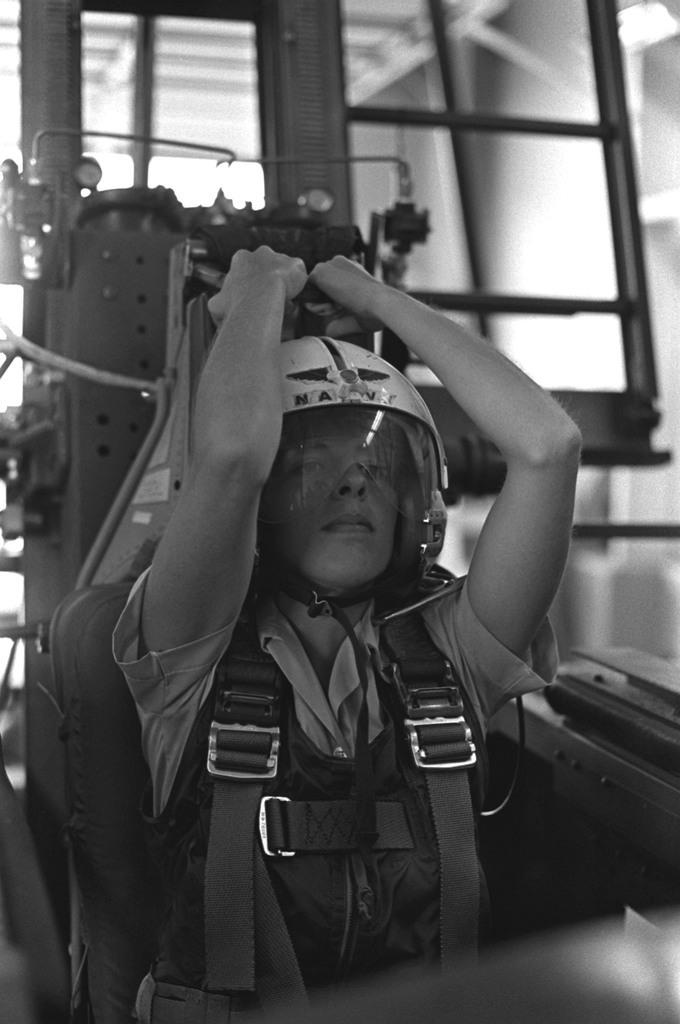Who is present in the image? There is a woman in the image. What is the woman doing in the image? The woman is sitting. What type of clothing is the woman wearing in the image? The woman is wearing a jacket and a helmet. What type of stem can be seen growing from the woman's helmet in the image? There is no stem growing from the woman's helmet in the image. 